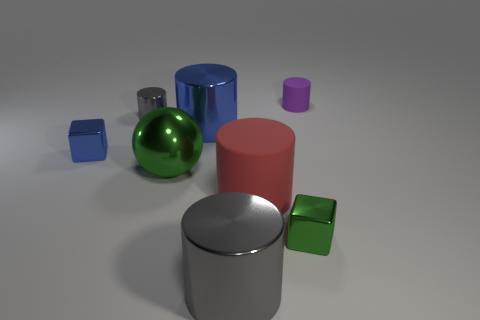Subtract all red cylinders. How many cylinders are left? 4 Subtract all yellow cylinders. Subtract all red cubes. How many cylinders are left? 5 Add 2 tiny blue blocks. How many objects exist? 10 Subtract all balls. How many objects are left? 7 Subtract all large metal cylinders. Subtract all balls. How many objects are left? 5 Add 5 tiny cylinders. How many tiny cylinders are left? 7 Add 1 large matte cylinders. How many large matte cylinders exist? 2 Subtract 0 red spheres. How many objects are left? 8 